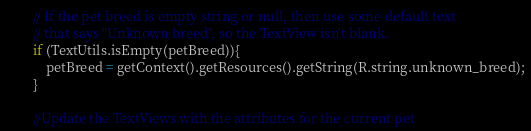<code> <loc_0><loc_0><loc_500><loc_500><_Java_>        // If the pet breed is empty string or null, then use some default text
        // that says "Unknown breed", so the TextView isn't blank.
        if (TextUtils.isEmpty(petBreed)){
            petBreed = getContext().getResources().getString(R.string.unknown_breed);
        }

        //Update the TextViews with the attributes for the current pet</code> 